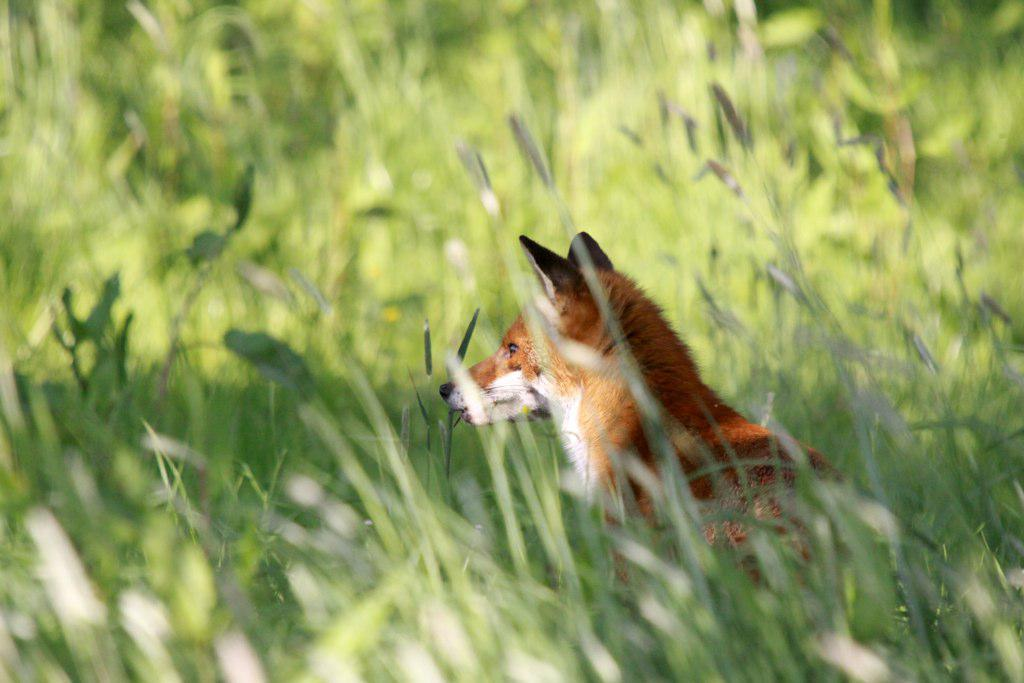What animal is present in the image? There is a fox in the image. Where is the fox located? The fox is in farmland. What can be seen in the background of the image? There are many plants visible in the background of the image. What type of peace symbol can be seen in the image? There is no peace symbol present in the image; it features a fox in farmland with plants in the background. 